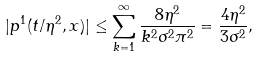<formula> <loc_0><loc_0><loc_500><loc_500>| p ^ { 1 } ( t / \eta ^ { 2 } , x ) | \leq \sum _ { k = 1 } ^ { \infty } \frac { 8 \eta ^ { 2 } } { k ^ { 2 } \sigma ^ { 2 } \pi ^ { 2 } } = \frac { 4 \eta ^ { 2 } } { 3 \sigma ^ { 2 } } ,</formula> 